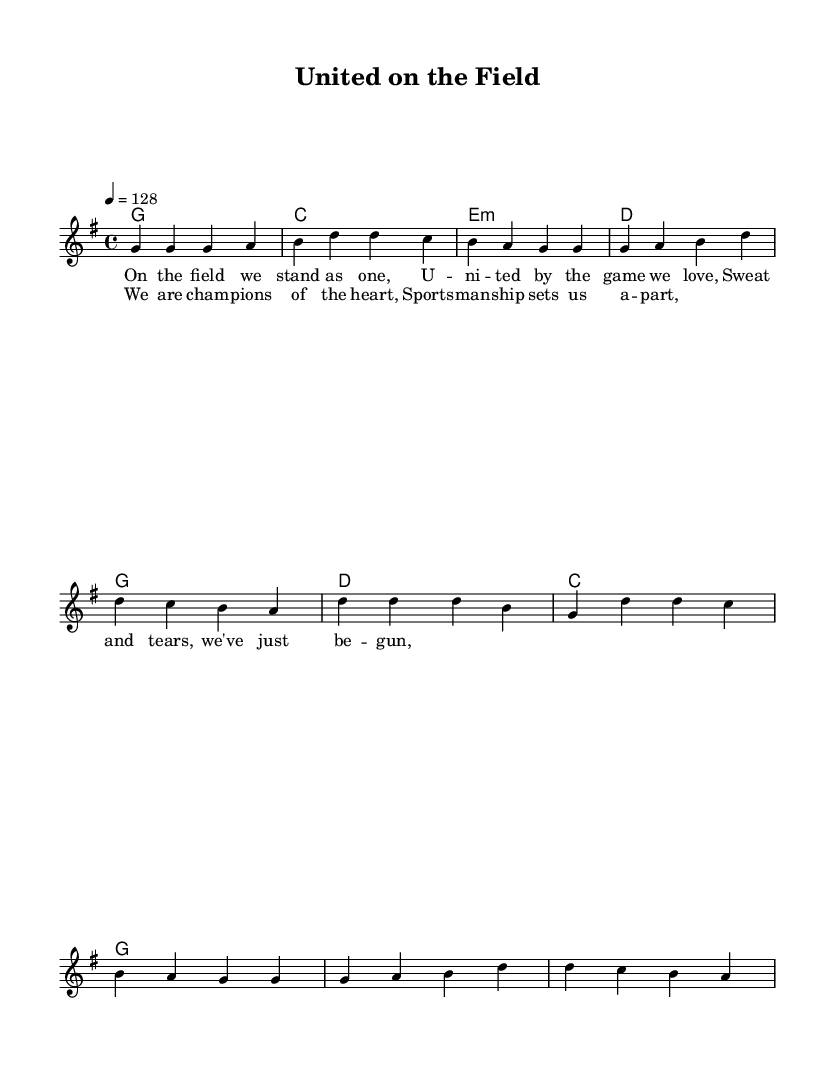What is the key signature of this music? The key signature is G major, which has one sharp (F#). This can be identified at the beginning of the staff where the key signature is notated.
Answer: G major What is the time signature of the music? The time signature is 4/4, which means there are four beats in each measure and a quarter note receives one beat. This is indicated at the beginning of the score.
Answer: 4/4 What is the tempo marking of this piece? The tempo marking is 128 beats per minute, indicated above the staff as "4 = 128". This shows the pace at which the piece should be played.
Answer: 128 How many measures are in the verse section? The verse section consists of five measures, as counted from the beginning of the verse melody line until the end of that section.
Answer: Five What are the first two notes of the chorus? The first two notes of the chorus are D and D, which can be seen in the melody part where the chorus starts. This detail can be easily identified at the beginning of the chorus section.
Answer: D, D What is the primary theme discussed in the lyrics? The primary theme in the lyrics is about unity and teamwork in sports, as highlighted by phrases indicating togetherness on the field and the spirit of sportsmanship. The lyrics reflect these sentiments and emotions.
Answer: Unity Which musical genre does this piece belong to? This piece belongs to the Country Rock genre, which can be inferred from the upbeat nature of the melody and the lyrical content celebrating team spirit, typical of this musical style.
Answer: Country Rock 